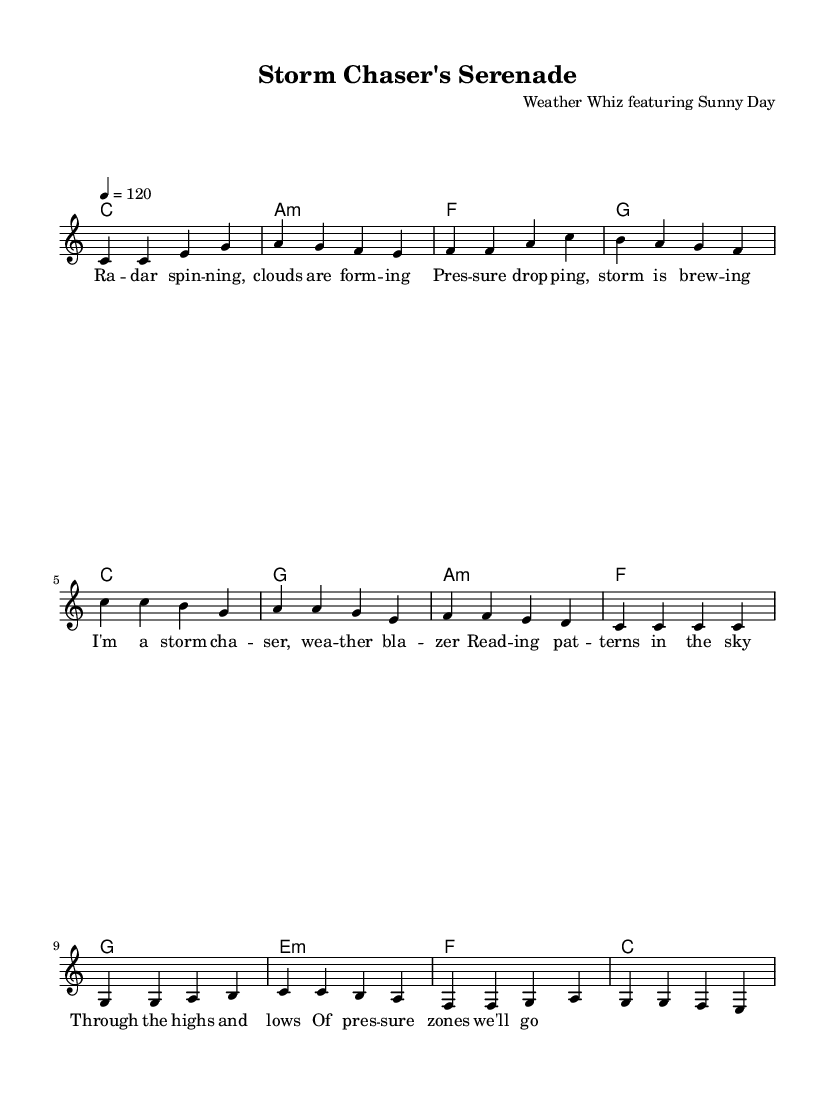What is the key signature of this music? The key signature is C major, which has no sharps or flats indicated. This is determined by looking at the music's global information section.
Answer: C major What is the time signature of this music? The time signature is 4/4, which means there are four beats per measure and a quarter note receives one beat. This is stated in the global section as well.
Answer: 4/4 What is the tempo marking for this piece? The tempo marking indicates a pace of 120 beats per minute, which is noted at the beginning as "4 = 120."
Answer: 120 How many sections are there in this song? The song consists of three main sections: verse, chorus, and bridge. This structure is evident from the different parts labeled in the score.
Answer: Three What chord follows the first chord in the verse? The first chord in the verse is C major, and the following chord is A minor, as indicated in the chord progression underneath the lyrics.
Answer: A minor Which section features the lyrics about "storm chaser" and "weather blazer"? These lyrics are found in the chorus section, as they directly correspond with the second set of lyrics provided in the score following the verse.
Answer: Chorus What progression of chords is used in the bridge? The bridge uses the chord progression G, E minor, F, C, as listed under the bridge chords section. This shows the harmonic movement in this particular section.
Answer: G, E minor, F, C 